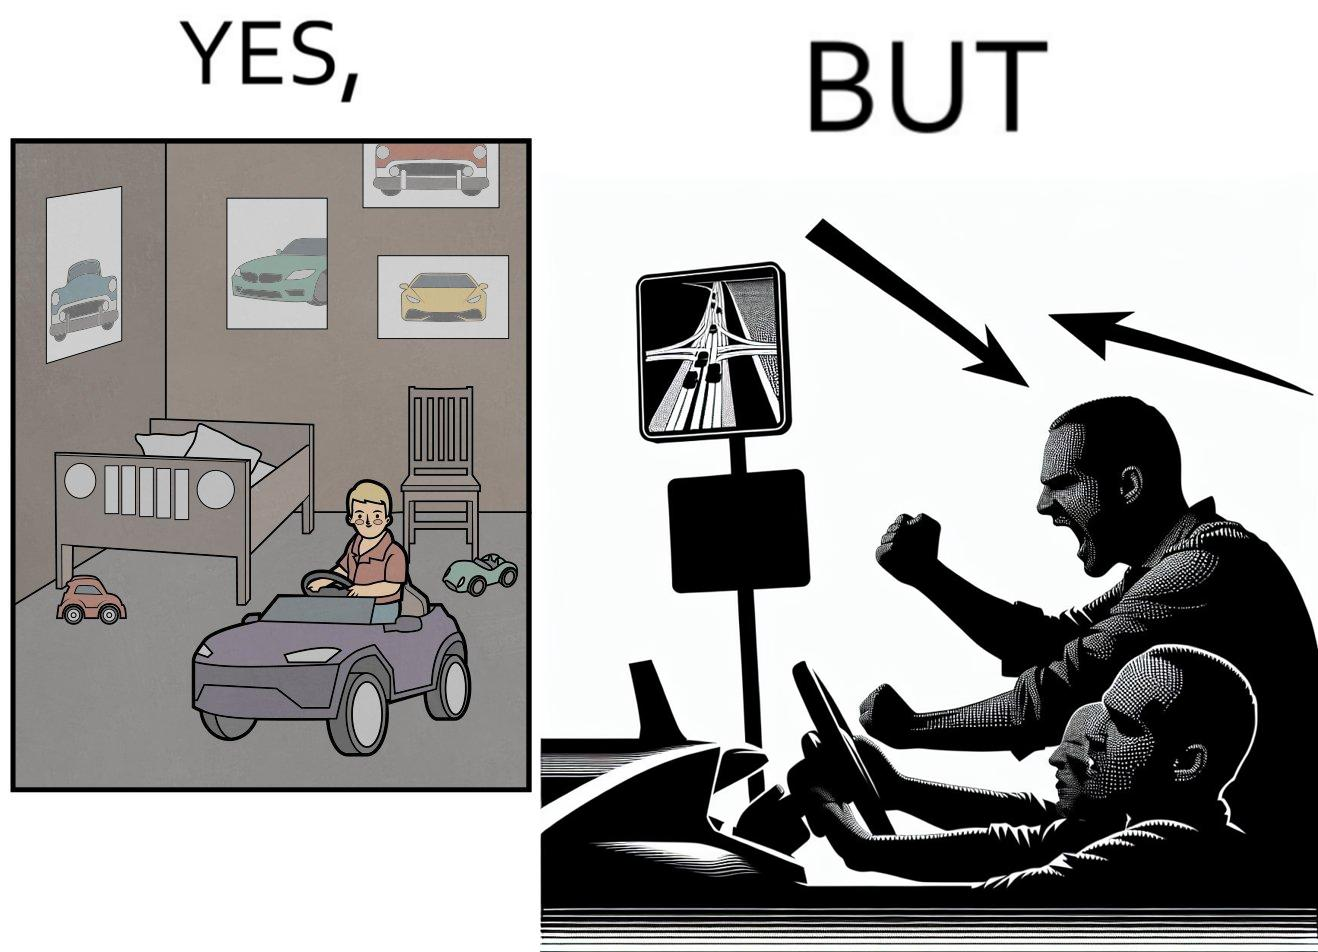Describe the satirical element in this image. The image is funny beaucse while the person as a child enjoyed being around cars, had various small toy cars and even rode a bigger toy car, as as grown up he does not enjoy being in a car during a traffic jam while he is driving . 